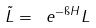Convert formula to latex. <formula><loc_0><loc_0><loc_500><loc_500>\tilde { L } = \ e ^ { - \i H } L</formula> 